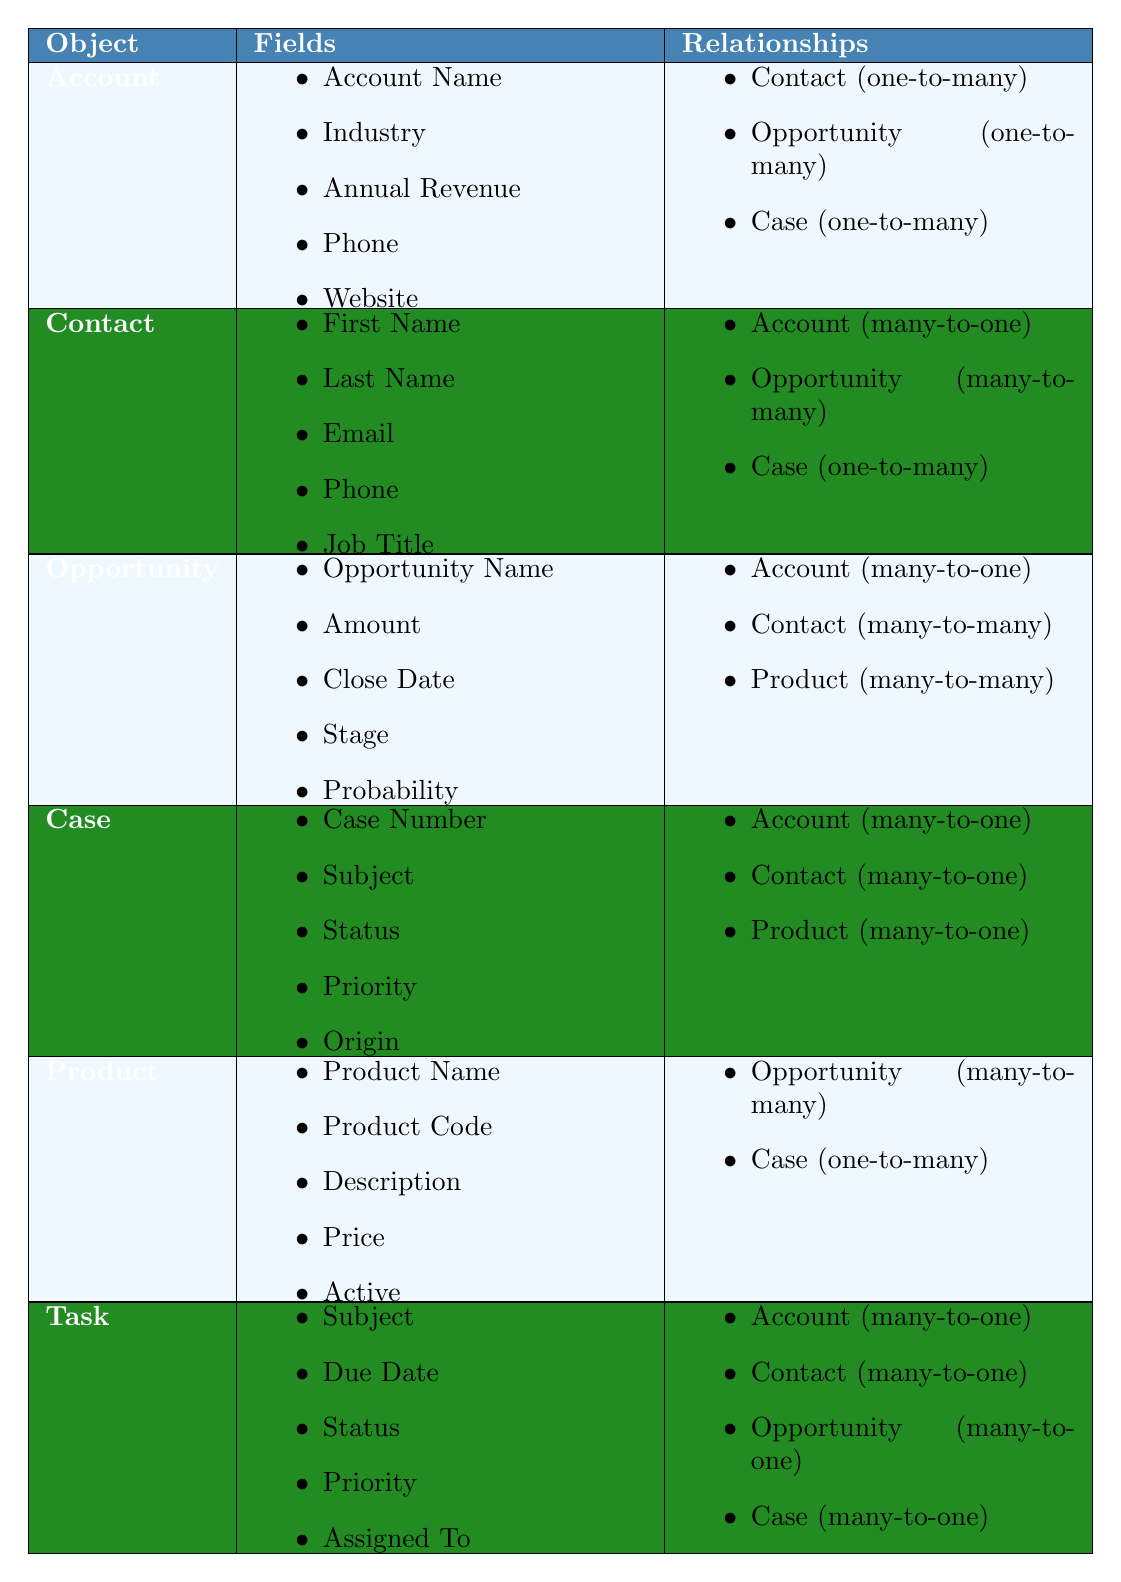What fields are included in the Account object? The Account object has the following fields listed: Account Name, Industry, Annual Revenue, Phone, and Website.
Answer: Account Name, Industry, Annual Revenue, Phone, Website How many relationships does the Opportunity object have? The Opportunity object has three relationships: Account (many-to-one), Contact (many-to-many), and Product (many-to-many). Therefore, it has a total of three relationships.
Answer: 3 Is the Contact object related to the Account object in a one-to-many relationship? The Contact object has a many-to-one relationship with the Account object, not a one-to-many. Thus, the statement is false.
Answer: No Which object has a one-to-many relationship with both Opportunity and Account? From the table, the Account object has a one-to-many relationship with the Opportunity object and also with Contact and Case, but the question asks for the one-to-many with Opportunity specifically. Hence, we keep focusing on Account only.
Answer: Account Which objects have a many-to-one relationship with the Case object? The Case object has three many-to-one relationships with Account, Contact, and Product.
Answer: Account, Contact, Product What is the only object that has a many-to-many relationship with both Opportunity and Product? The only relationships that are marked as many-to-many are between Opportunity and Contact, and between Opportunity and Product. Hence, the object relevant to many-to-many with Product is Opportunity directly.
Answer: Opportunity How many fields does the Product object have? The Product object lists five fields: Product Name, Product Code, Description, Price, and Active.
Answer: 5 Which object is related to the Task object as a one-to-many relationship? The Task object has many one-to-many relationships, and one of them is with the Case object. Thus, the Task object can relate to Case in a one-to-many manner among others too.
Answer: Case Are there more fields in the Contact object than in the Account object? The Contact object has five fields, which are the same as the five fields in the Account object, therefore, they are equal, not more.
Answer: No What is the relationship type between Opportunity and Contact? The relationship type between Opportunity and Contact is many-to-many, as indicated in the relationships section for both objects.
Answer: Many-to-many 